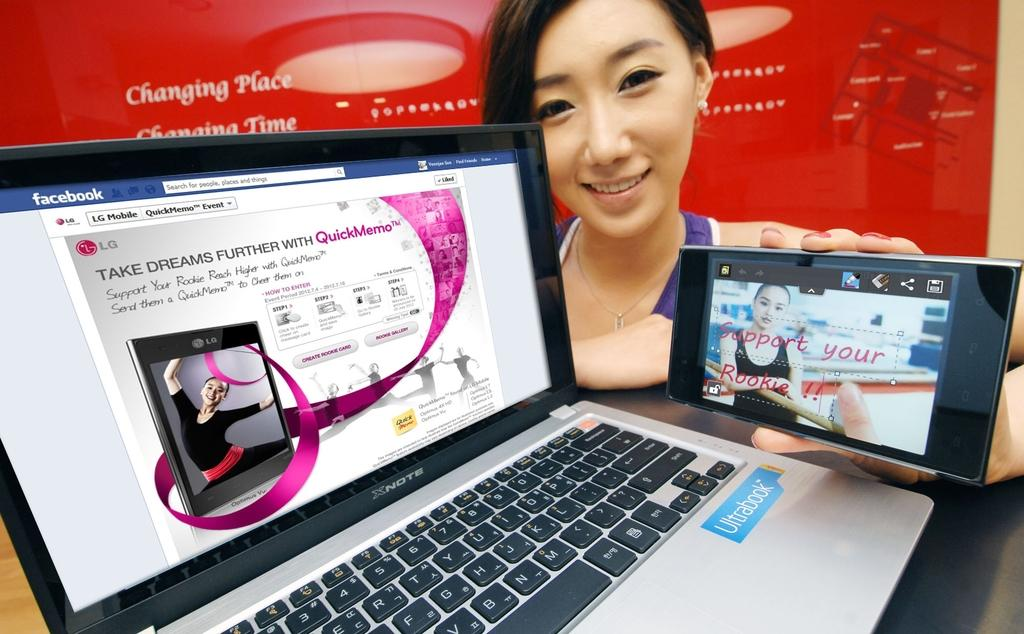Provide a one-sentence caption for the provided image. Girl holding phone by the laptop that has a blue sticker with the word Ultrabook. 